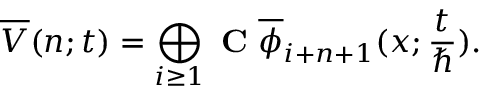Convert formula to latex. <formula><loc_0><loc_0><loc_500><loc_500>\overline { V } ( n ; t ) = \bigoplus _ { i \geq 1 } C \overline { \phi } _ { i + n + 1 } ( x ; \frac { t } { } ) .</formula> 